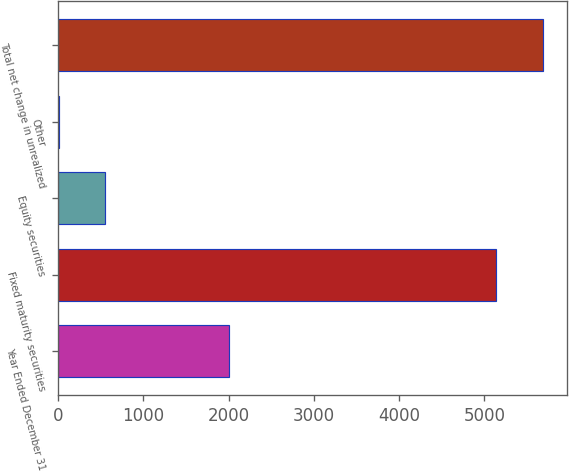Convert chart to OTSL. <chart><loc_0><loc_0><loc_500><loc_500><bar_chart><fcel>Year Ended December 31<fcel>Fixed maturity securities<fcel>Equity securities<fcel>Other<fcel>Total net change in unrealized<nl><fcel>2008<fcel>5137<fcel>552.4<fcel>5<fcel>5684.4<nl></chart> 